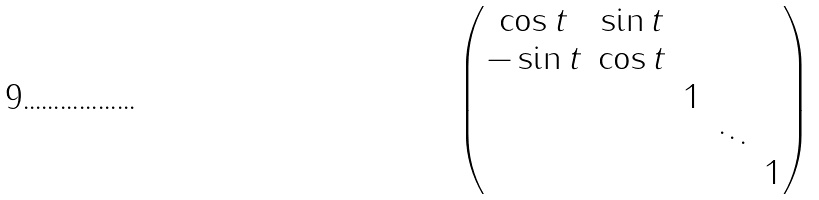<formula> <loc_0><loc_0><loc_500><loc_500>\begin{pmatrix} \cos t & \sin t \\ - \sin t & \cos t \\ & & 1 \\ & & & \ddots \\ & & & & 1 \end{pmatrix}</formula> 